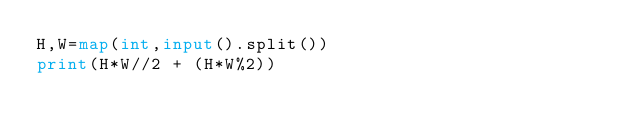<code> <loc_0><loc_0><loc_500><loc_500><_Python_>H,W=map(int,input().split())
print(H*W//2 + (H*W%2))</code> 